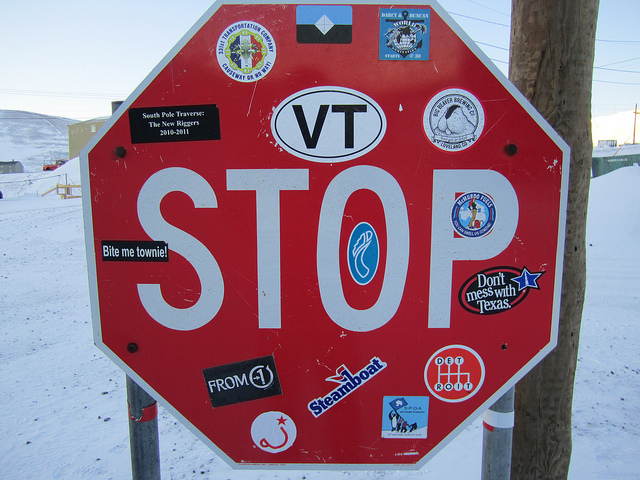Identify and read out the text in this image. VT STOP Steamboat FROM Bite T I O R J F D 1 Texas with mess Don't New The Rlgger's 2011 2010 Polt me 